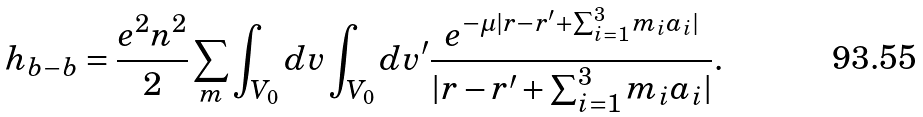<formula> <loc_0><loc_0><loc_500><loc_500>h _ { b - b } = \frac { e ^ { 2 } n ^ { 2 } } { 2 } \sum _ { m } \int _ { V _ { 0 } } d v \int _ { V _ { 0 } } d v ^ { \prime } \frac { e ^ { - \mu | r - r ^ { \prime } + \sum _ { i = 1 } ^ { 3 } m _ { i } a _ { i } | } } { | r - r ^ { \prime } + \sum _ { i = 1 } ^ { 3 } m _ { i } a _ { i } | } .</formula> 